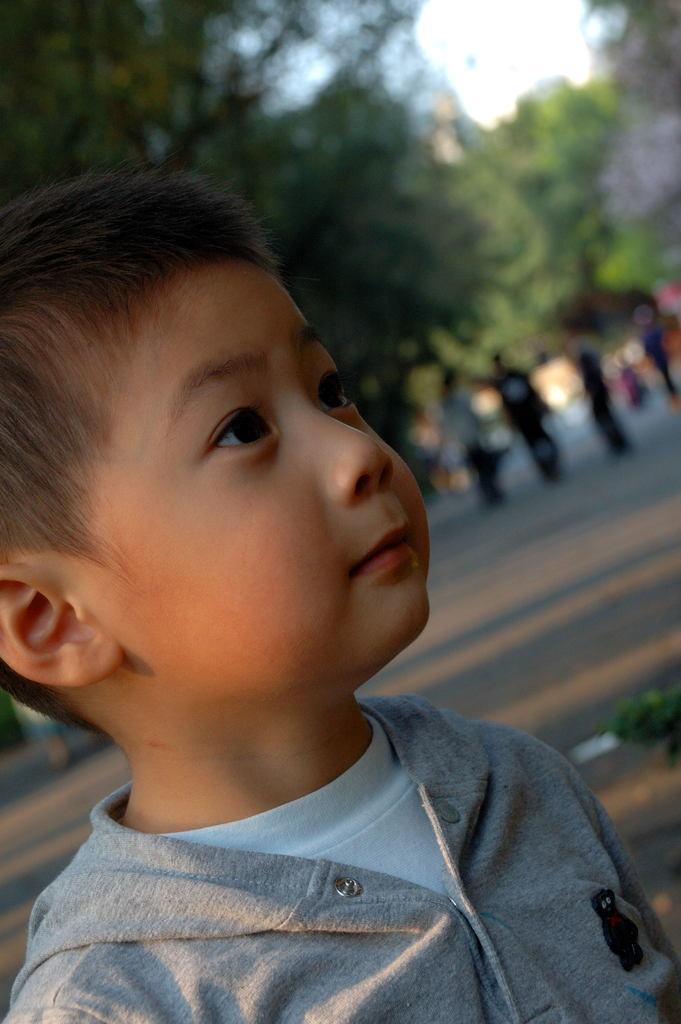In one or two sentences, can you explain what this image depicts? At the bottom of this image, there is a boy in a gray color t-shirt, watching something. In the background, there are persons on the road, there are trees and the sky. 